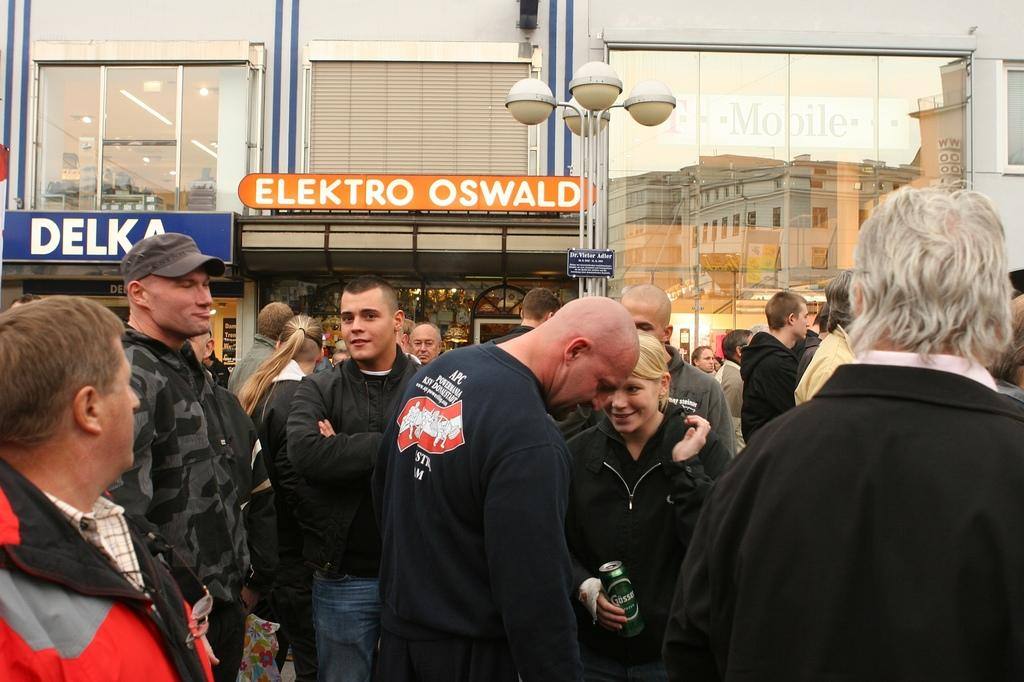What is the main subject of the image? The main subject of the image is a crowd. What can be seen in the background of the image? There are many buildings with names in the background. What type of structures are present in the image? There are light poles in the image. What type of store can be seen in the image? There is no store present in the image; it features a crowd and buildings with names in the background. What type of shade is provided by the light poles in the image? The light poles in the image do not provide shade; they are used for illumination. 